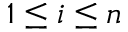<formula> <loc_0><loc_0><loc_500><loc_500>1 \leq i \leq n</formula> 